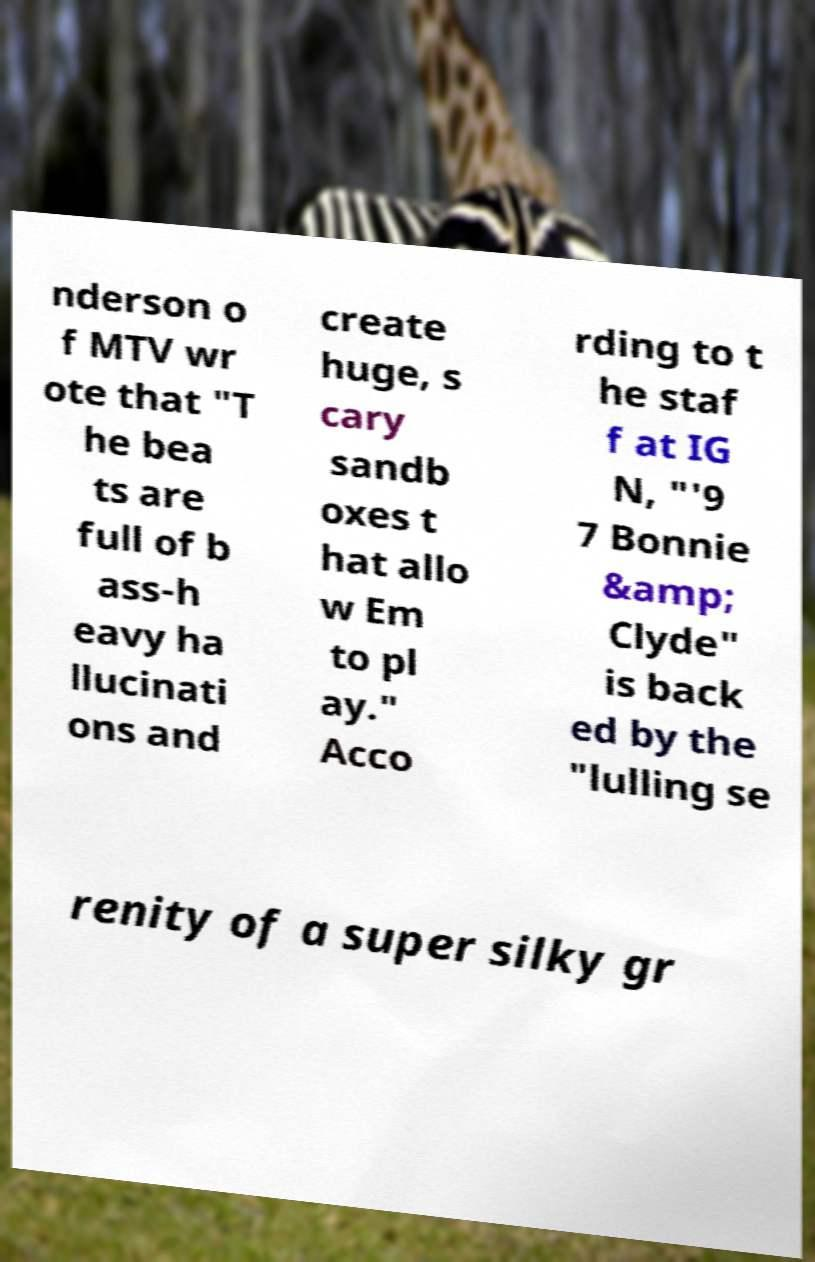For documentation purposes, I need the text within this image transcribed. Could you provide that? nderson o f MTV wr ote that "T he bea ts are full of b ass-h eavy ha llucinati ons and create huge, s cary sandb oxes t hat allo w Em to pl ay." Acco rding to t he staf f at IG N, "'9 7 Bonnie &amp; Clyde" is back ed by the "lulling se renity of a super silky gr 